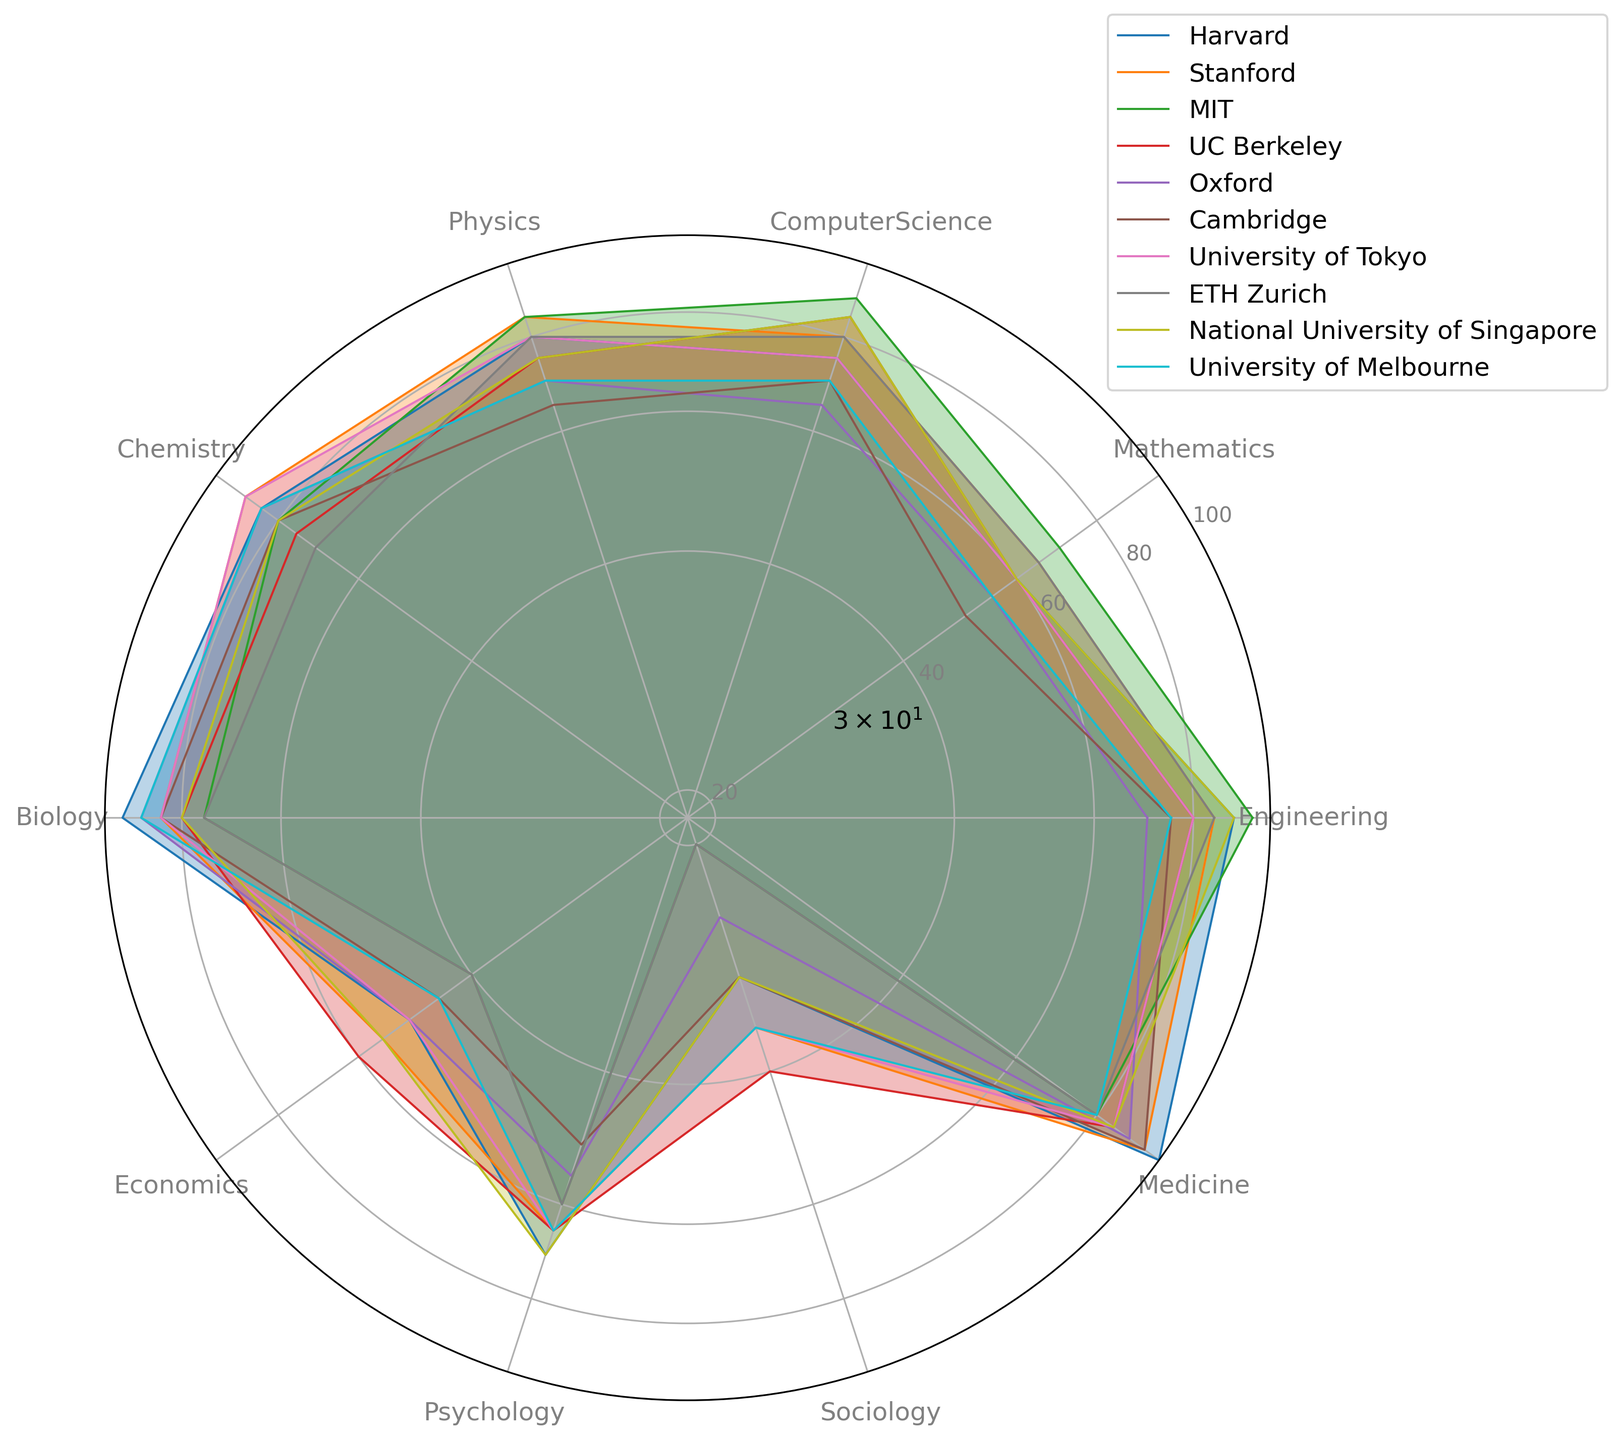Which university has the highest publication volume in Biology? Look at the radar chart and identify which university has the highest value for Biology. MIT, Cambridge, Harvard, Oxford, and the University of Melbourne have scores above 80. The highest score is 95, which is achieved by Harvard.
Answer: Harvard Which university has the lowest publication volume in Sociology? Check the radar chart for the lowest values in the Sociology category for each university. MIT and ETH Zurich have the lowest value of 20.
Answer: MIT, ETH Zurich Which universities have equal publication volumes in Physics? Identify universities that have the same values in the Physics category on the radar chart. MIT, Stanford, and ETH Zurich have publication volumes of 85.
Answer: MIT, Stanford, ETH Zurich What is the average publication volume in Mathematics for Harvard, Stanford, and Cambridge? Add the values for Mathematics for Harvard, Stanford, and Cambridge: (60 + 65 + 50). Divide by 3 to get the average. 60 + 65 + 50 = 175; 175 / 3 = 58.33.
Answer: 58.33 How does the publication volume in Engineering at Stanford compare to UC Berkeley? Compare the values in the Engineering category between Stanford (85) and UC Berkeley (80). Stanford has a higher publication volume.
Answer: Stanford > UC Berkeley Which university has a higher average publication volume in Chemistry and Biology: Oxford or Cambridge? Calculate the average in both fields for Oxford and Cambridge. Cambridge: (80 + 85) / 2 = 82.5; Oxford: (85 + 90) / 2 = 87.5. Oxford's average is higher.
Answer: Oxford What is the sum of publication volumes in Economics and Medicine for the National University of Singapore? Add the values for Economics and Medicine for the National University of Singapore: (55 + 85). 55 + 85 = 140.
Answer: 140 Which university stands out most in Medicine based on the radar chart? Look for the university with the highest value in the Medicine category. Harvard stands out the most with a value of 100.
Answer: Harvard What is the difference in publication volume in Computer Science between UC Berkeley and the University of Tokyo? Subtract the value of UC Berkeley from University of Tokyo's value in the Computer Science category: 85 - 85 = 0. Both have the same value.
Answer: 0 Which university shows a more balanced publication volume across all fields: Harvard or Stanford? Observe the radar chart to see the spread of publication volumes across fields for each university. Harvard's values are more spread out but generally high, whereas Stanford's values are more centered and balanced across the categories.
Answer: Stanford 